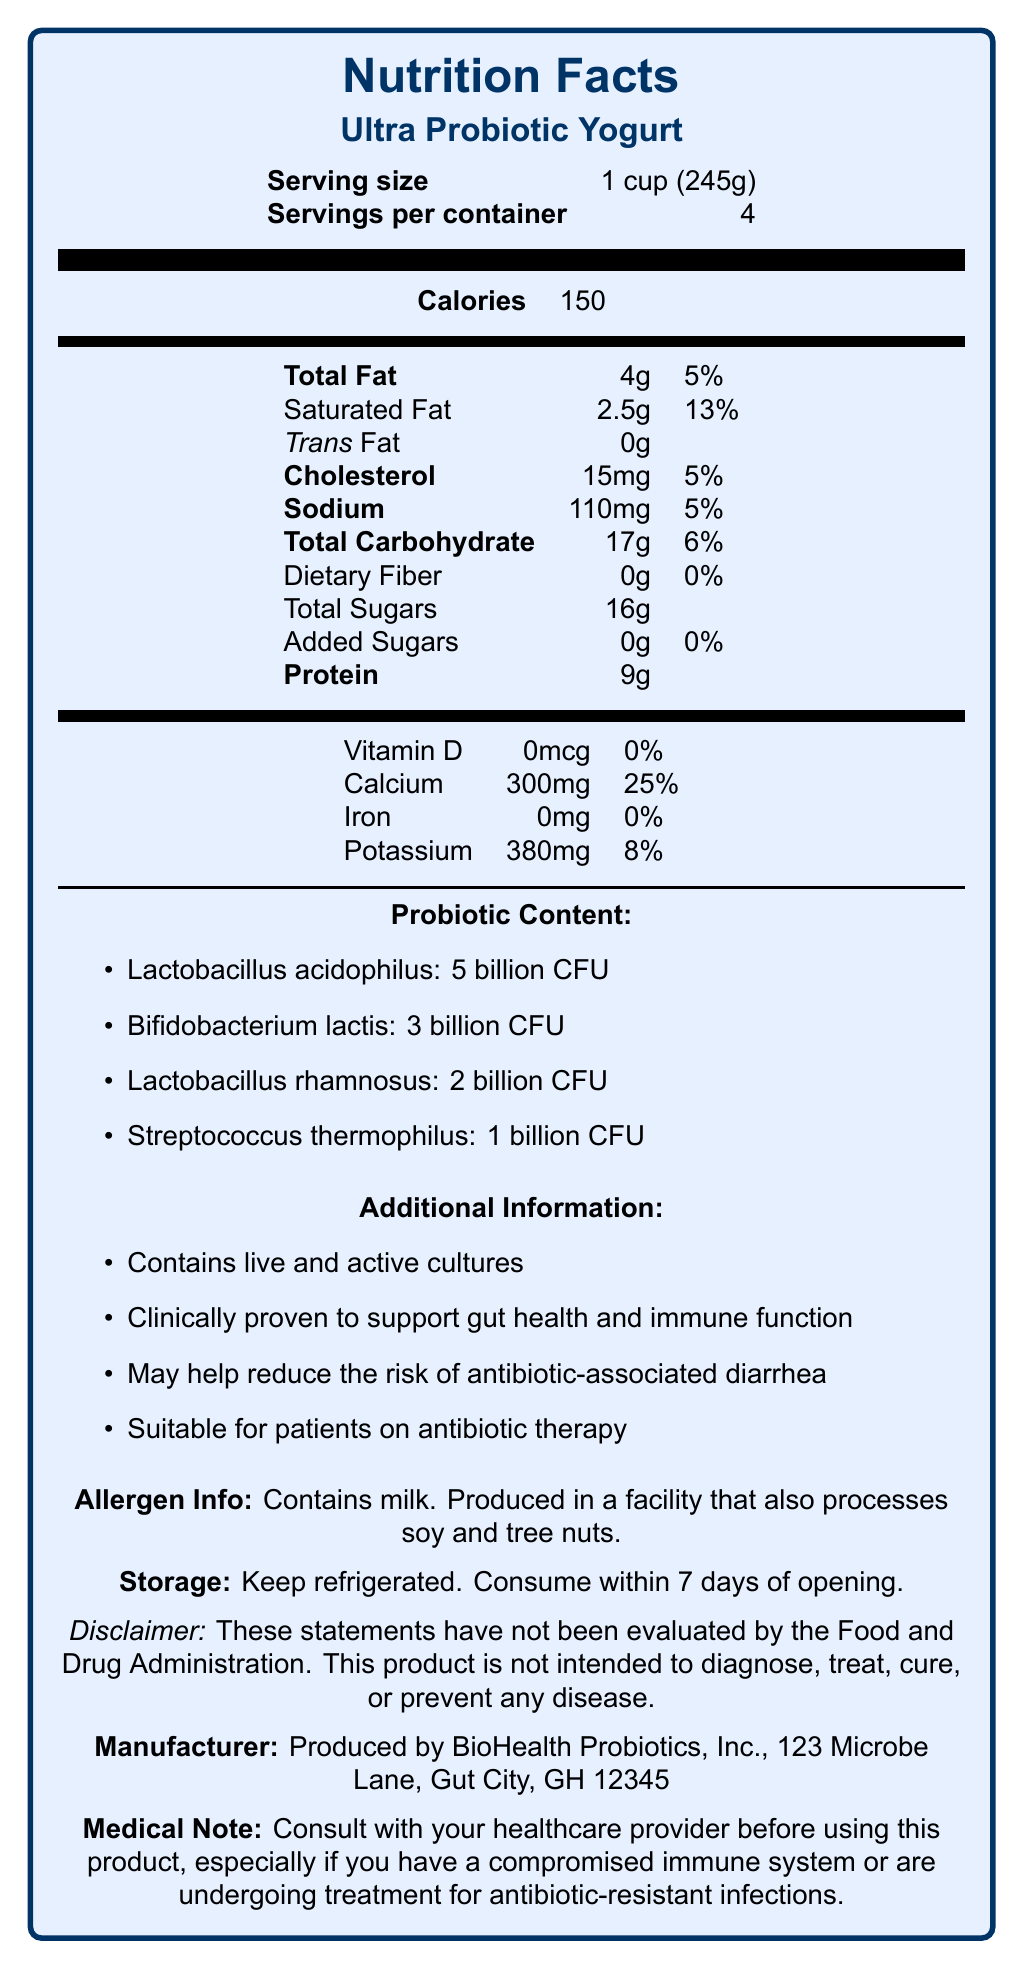what is the serving size? The serving size is clearly stated as "1 cup (245g)" in the document.
Answer: 1 cup (245g) what is the total amount of calories per serving? The total amount of calories per serving is listed as 150 in the document.
Answer: 150 how much Vitamin D does one serving provide? The document specifies that one serving contains 0mcg of Vitamin D.
Answer: 0mcg how much protein is in each serving? The amount of protein per serving is noted as 9g in the document.
Answer: 9g how much added sugar does this product have? The document states that the product contains 0g of added sugars.
Answer: 0g which probiotic is present in the highest amount? A. Lactobacillus acidophilus B. Bifidobacterium lactis C. Lactobacillus rhamnosus D. Streptococcus thermophilus The document shows that Lactobacillus acidophilus is present at 5 billion CFU, which is the highest amount among the probiotics listed.
Answer: A what percentage of the daily value for calcium does each serving provide? A. 5% B. 8% C. 25% D. 13% The document indicates that each serving provides 25% of the daily value for calcium.
Answer: C is this product suitable for individuals with a compromised immune system? The medical note advises consulting with a healthcare provider before using this product if you have a compromised immune system, implying caution.
Answer: No does this product contain any tree nuts? The allergen info states that the product is produced in a facility that also processes soy and tree nuts, but it does not contain them.
Answer: No summarize the main idea of the document. The document provides detailed nutritional information about Ultra Probiotic Yogurt, highlighting its probiotic content and additional health benefits, along with allergen and storage information.
Answer: Ultra Probiotic Yogurt is a probiotic-rich food that supports gut health and immune function. It contains various probiotics, minimal added sugars, and nutrients like calcium and potassium. It is suitable for patients on antibiotic therapy but requires consultation with healthcare providers for those with compromised immune systems. what is the recommended storage instruction for this product? The document advises keeping the product refrigerated and consuming it within 7 days of opening.
Answer: Keep refrigerated. Consume within 7 days of opening. how many servings are there per container? The document states that there are 4 servings per container.
Answer: 4 which company produces this product? The document mentions the manufacturer as BioHealth Probiotics, Inc.
Answer: BioHealth Probiotics, Inc. can probiotics in this product solely prevent antibiotic-resistant infections? While the product may support gut health and immune function, the document does not provide enough information to claim it can solely prevent antibiotic-resistant infections.
Answer: Not enough information how much dietary fiber does each serving contain? The amount of dietary fiber per serving is listed as 0g in the document.
Answer: 0g how much potassium does each serving provide? The document specifies that each serving contains 380mg of potassium.
Answer: 380mg what is the daily value percentage of saturated fat per serving? The percentage of daily value for saturated fat per serving is 13%, as stated in the document.
Answer: 13% what is the total carbohydrate amount per serving? The document lists the total carbohydrate amount per serving as 17g.
Answer: 17g 